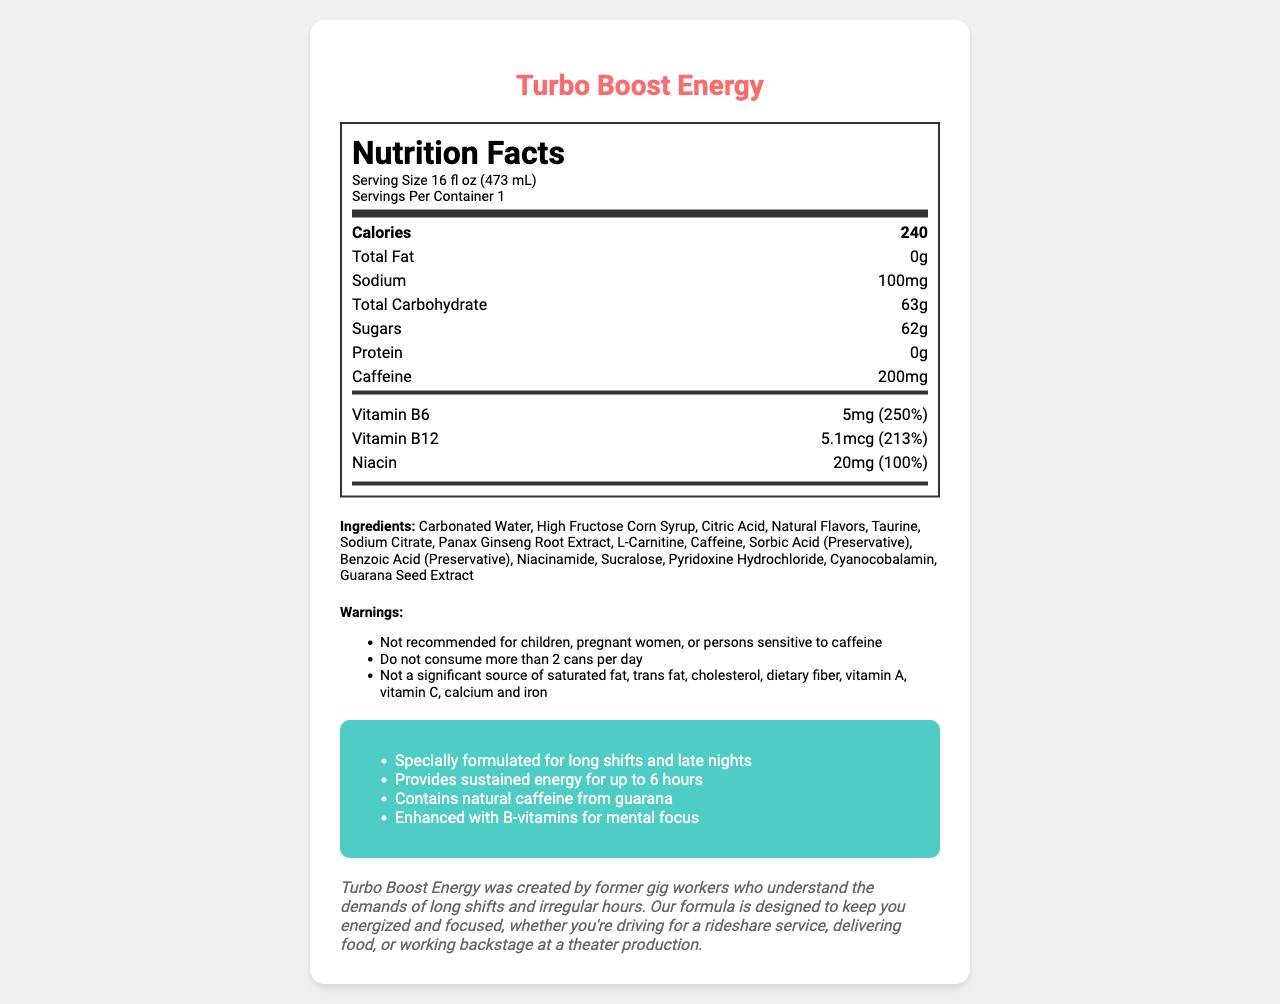what is the serving size of Turbo Boost Energy? The serving size is clearly mentioned in the "Nutrition Facts" section under "Serving Size".
Answer: 16 fl oz (473 mL) how many calories are in one container of Turbo Boost Energy? The number of calories is displayed prominently in the "Nutrition Facts" section as 240 calories.
Answer: 240 what percentage of Vitamin B6's daily value is in one serving? The amount of Vitamin B6 and its daily value percentage (250%) are listed under the "vitamins" section in the "Nutrition Facts".
Answer: 250% how much sodium does Turbo Boost Energy contain? The amount of sodium is listed under the "Nutrition Facts" in the sodium section.
Answer: 100mg what are the main ingredients in Turbo Boost Energy? The main ingredients are listed under the "Ingredients" section of the document.
Answer: Carbonated Water, High Fructose Corn Syrup, Citric Acid, Natural Flavors, Taurine, Sodium Citrate, Panax Ginseng Root Extract, L-Carnitine, Caffeine, Sorbic Acid (Preservative), Benzoic Acid (Preservative), Niacinamide, Sucralose, Pyridoxine Hydrochloride, Cyanocobalamin, Guarana Seed Extract how much caffeine is in Turbo Boost Energy? The amount of caffeine is displayed in the "Nutrition Facts" section under "Caffeine".
Answer: 200mg how long does Turbo Boost Energy claim to provide sustained energy? One of the marketing claims mentions that Turbo Boost Energy provides sustained energy for up to 6 hours.
Answer: up to 6 hours is Turbo Boost Energy recommended for pregnant women? The warning section clearly states that it is not recommended for children, pregnant women, or persons sensitive to caffeine.
Answer: No A. I, II, III
B. II, III, V
C. I, IV, V
D. I, II, III, IV, V All the statements listed correspond to the warnings provided in the document.
Answer: D. I, II, III, IV, V is Turbo Boost Energy a significant source of dietary fiber? The warning section states that it is not a significant source of dietary fiber.
Answer: No summarize the document The document provides detailed nutritional information, ingredients, marketing claims, warnings, and brand story about Turbo Boost Energy drink, highlighting its suitability for gig workers.
Answer: Turbo Boost Energy is a 16 fl oz energy drink designed for long shifts and late nights, favored by gig workers. It contains 240 calories, 200mg caffeine, 63g total carbohydrates, and 62g sugars per serving. It provides significant daily values of vitamins such as Vitamin B6 (250%), Vitamin B12 (213%), and Niacin (100%). The drink's ingredients include Carbonated Water, High Fructose Corn Syrup, and various other compounds to enhance energy and focus. However, it is not recommended for children, pregnant women, or persons sensitive to caffeine. The brand was created by former gig workers and emphasizes sustained energy for up to 6 hours. how much protein is in Turbo Boost Energy? The amount of protein is listed in the "Nutrition Facts" section and is 0g.
Answer: 0g who created Turbo Boost Energy? The brand story mentions that Turbo Boost Energy was created by former gig workers.
Answer: Former gig workers what is the function of Sorbic Acid in Turbo Boost Energy? The document lists ingredients including Sorbic Acid but does not specify its function; typically, Sorbic Acid is a preservative.
Answer: Cannot be determined 